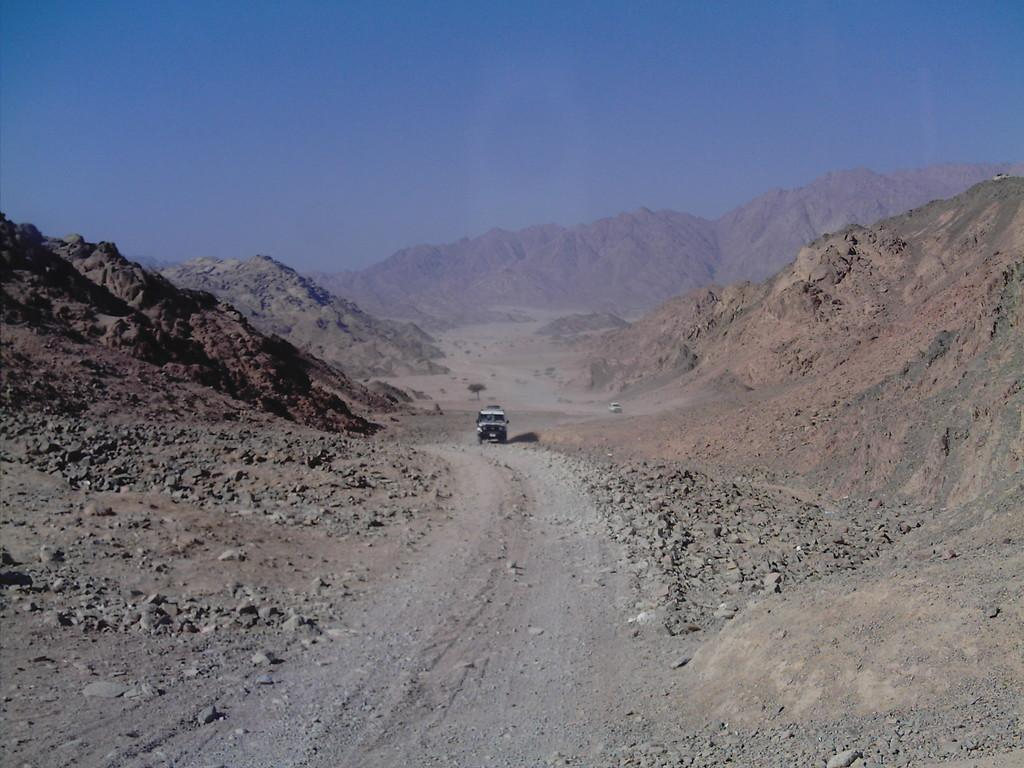What is happening on the road in the image? There is a car moving on the road in the image. What can be seen on both sides of the road? There are mountains on both sides of the road in the image. What is visible in the backdrop of the image? There is another mountain in the backdrop of the image. What is the condition of the sky in the image? The sky is clear in the image. Where is the farm located in the image? There is no farm present in the image. What type of house can be seen in the image? There is no house present in the image. 